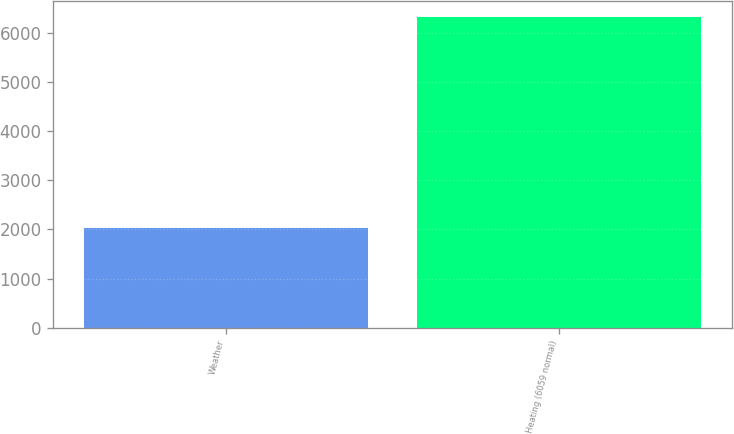<chart> <loc_0><loc_0><loc_500><loc_500><bar_chart><fcel>Weather<fcel>Heating (6059 normal)<nl><fcel>2018<fcel>6327<nl></chart> 